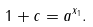Convert formula to latex. <formula><loc_0><loc_0><loc_500><loc_500>1 + c = a ^ { x _ { 1 } } .</formula> 